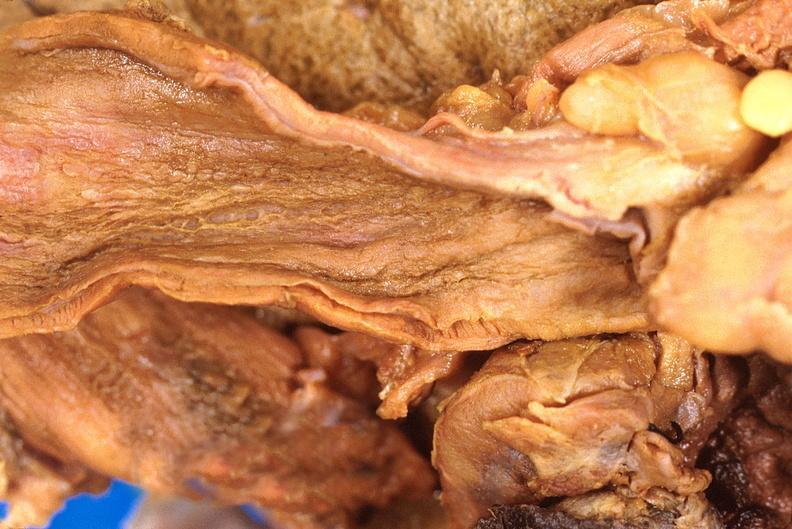does cm show stomach, necrotizing esophagitis and gastritis, sulfuric acid ingested as suicide attempt?
Answer the question using a single word or phrase. No 